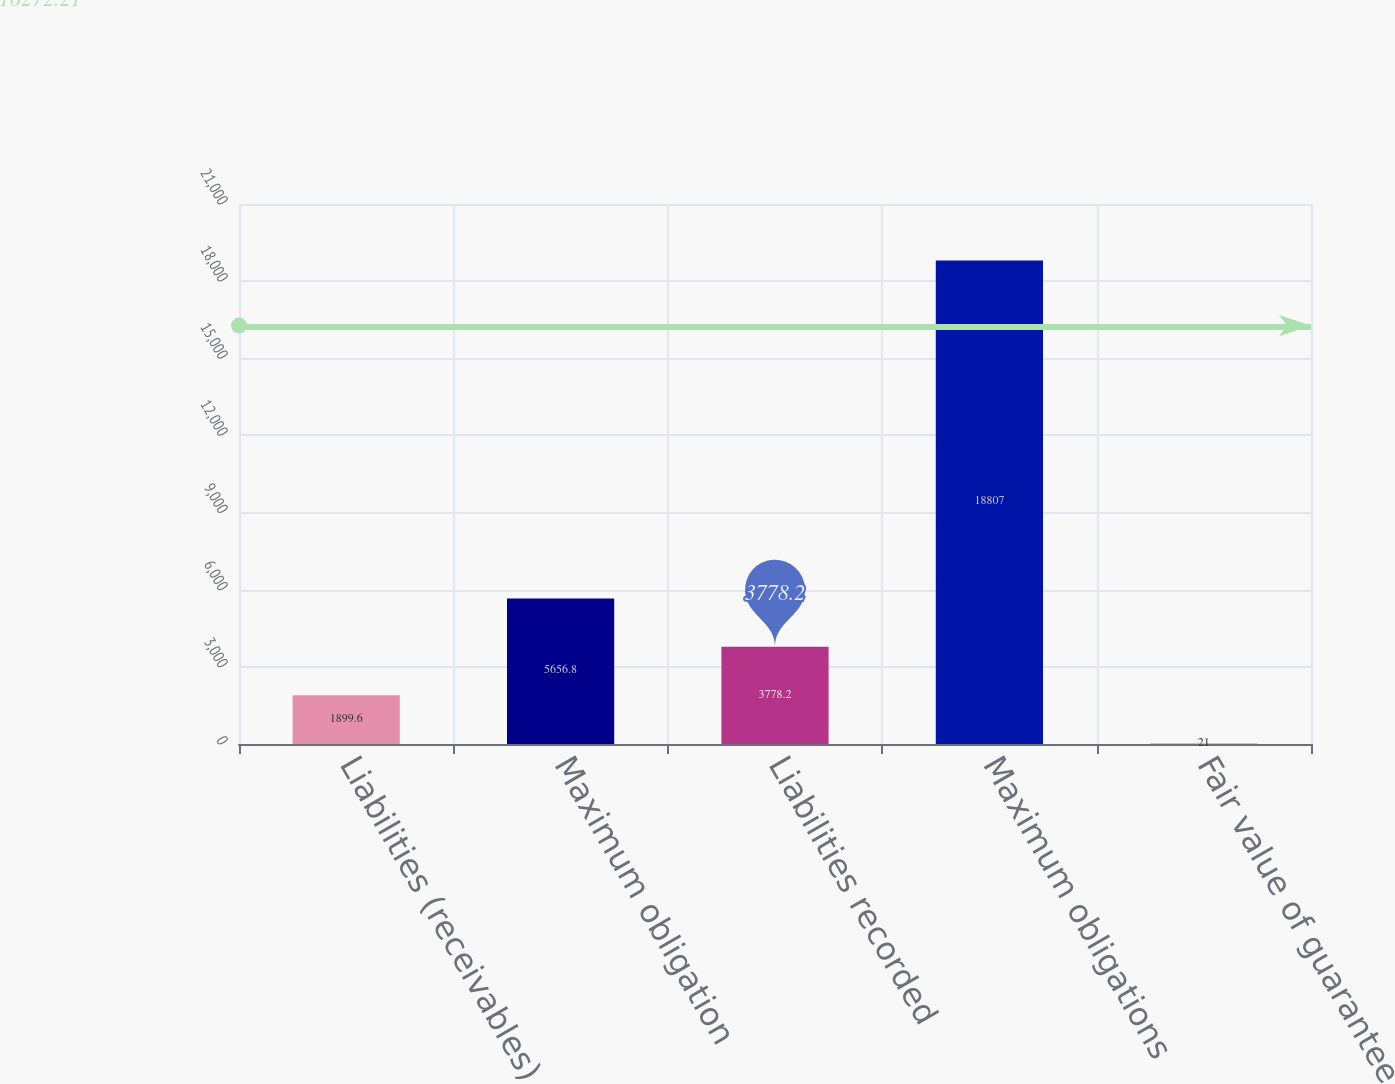Convert chart. <chart><loc_0><loc_0><loc_500><loc_500><bar_chart><fcel>Liabilities (receivables)<fcel>Maximum obligation<fcel>Liabilities recorded<fcel>Maximum obligations<fcel>Fair value of guarantee<nl><fcel>1899.6<fcel>5656.8<fcel>3778.2<fcel>18807<fcel>21<nl></chart> 